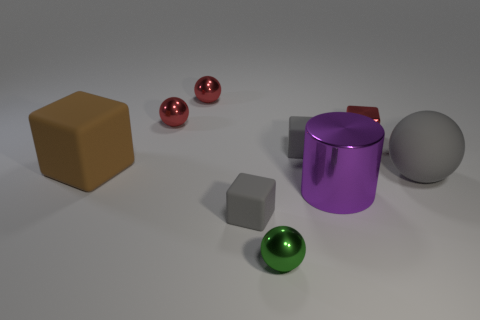Can you describe the lighting in the scene? The lighting in the scene appears to be soft and diffused, coming from above. It creates gentle shadows below the objects, indicating a light source that isn't too harsh or direct. 